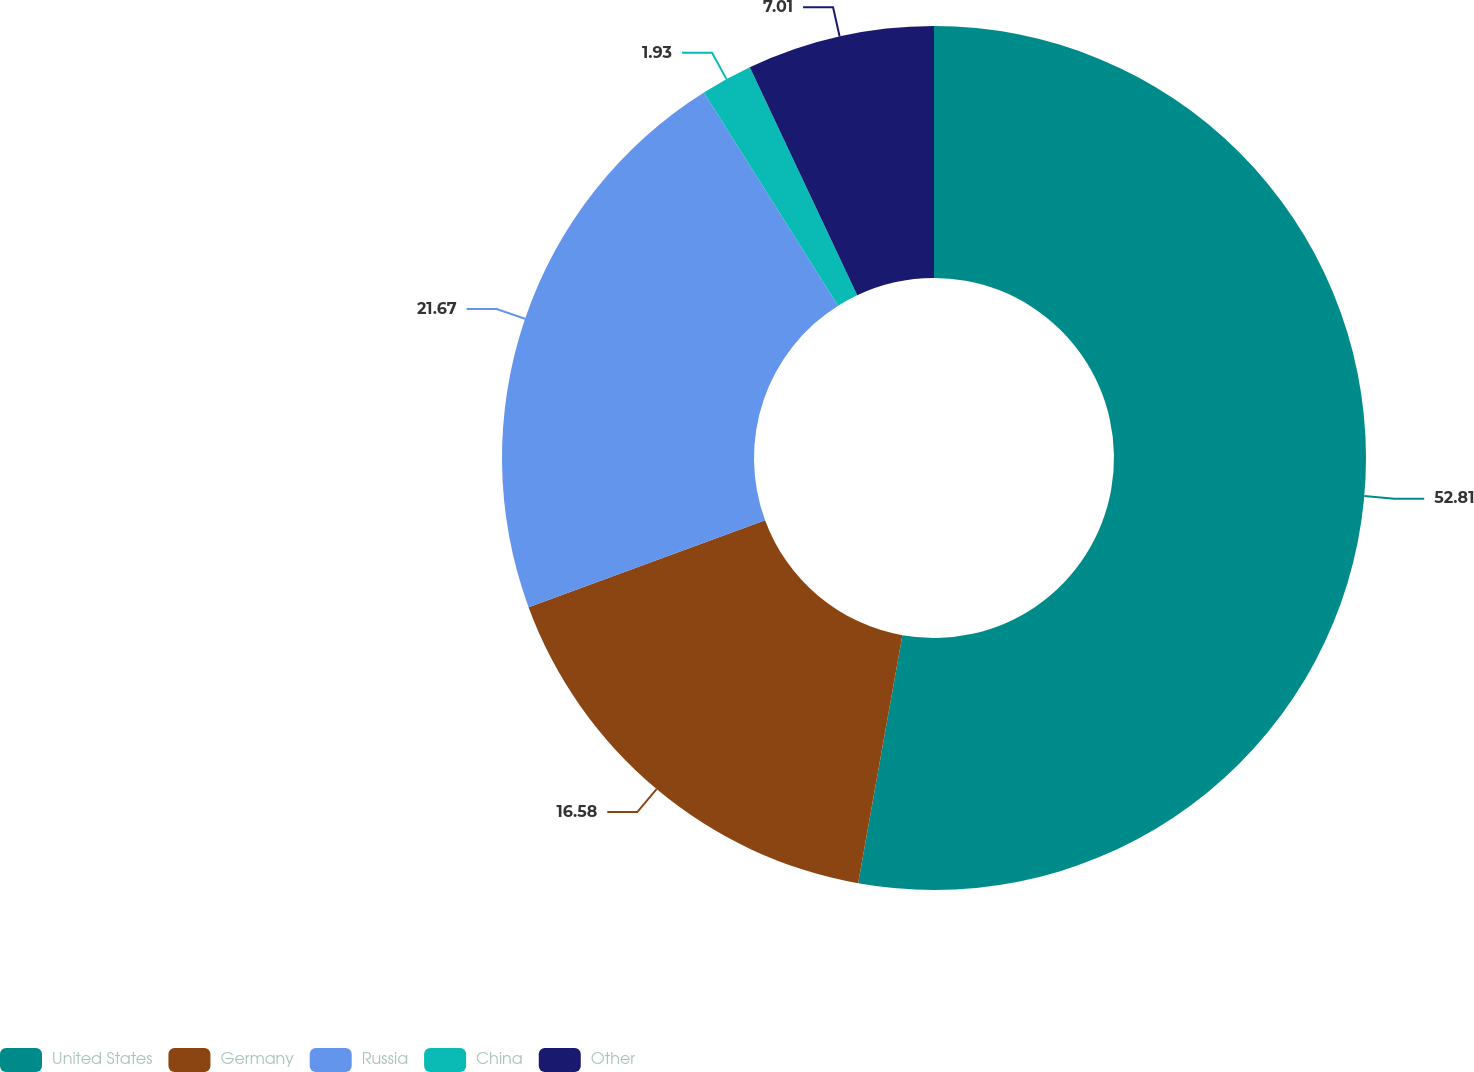Convert chart. <chart><loc_0><loc_0><loc_500><loc_500><pie_chart><fcel>United States<fcel>Germany<fcel>Russia<fcel>China<fcel>Other<nl><fcel>52.81%<fcel>16.58%<fcel>21.67%<fcel>1.93%<fcel>7.01%<nl></chart> 